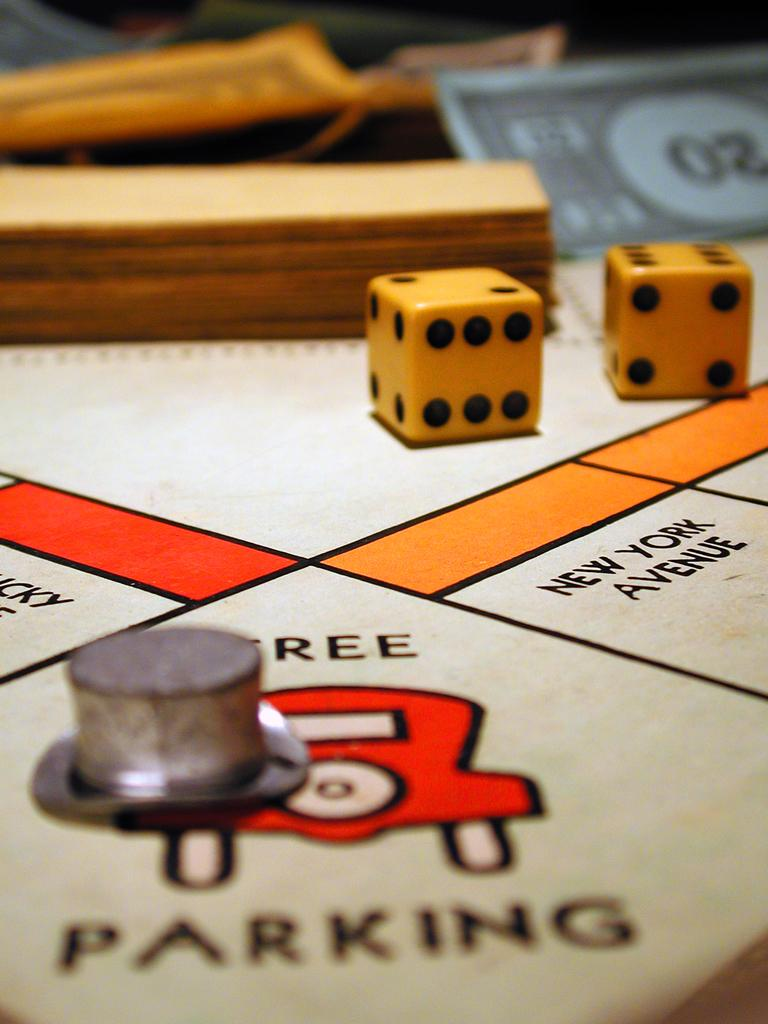What objects are present in the image that are used in games? There are two dice in the image, which are commonly used in games. What type of money-related item can be seen in the image? There is a currency note in the image. What type of paper items are present in the image? There are papers in the image. Can you describe the object with text and drawing in the image? The object with text and drawing in the image is likely a note or document. Are there any cobwebs visible in the image? There is no mention of cobwebs in the provided facts, and therefore it cannot be determined if any are present in the image. 